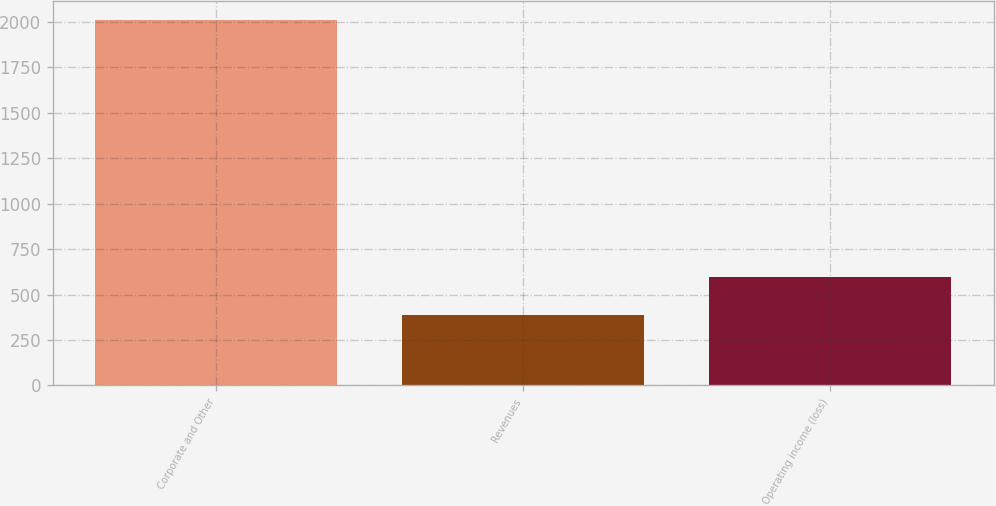Convert chart. <chart><loc_0><loc_0><loc_500><loc_500><bar_chart><fcel>Corporate and Other<fcel>Revenues<fcel>Operating income (loss)<nl><fcel>2012<fcel>390<fcel>597<nl></chart> 